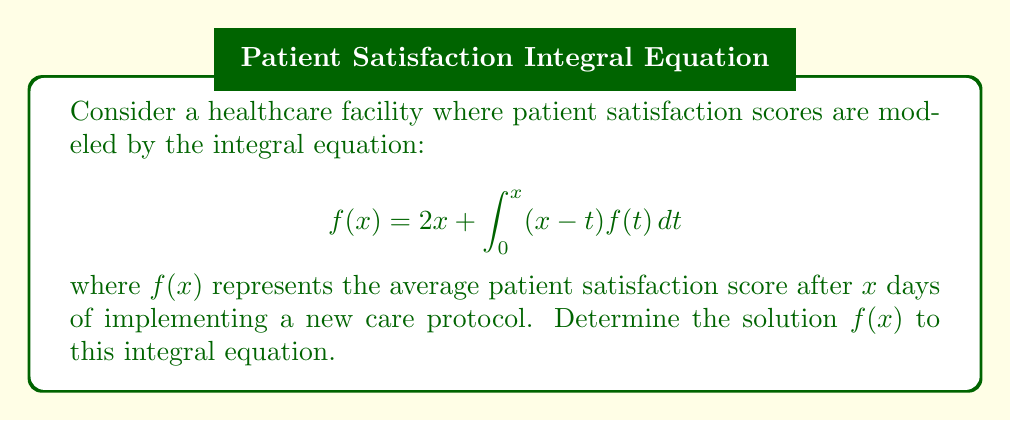Teach me how to tackle this problem. Let's solve this step-by-step:

1) First, we differentiate both sides of the equation with respect to $x$:

   $$f'(x) = 2 + \int_0^x f(t)dt + (x-x)f(x) = 2 + \int_0^x f(t)dt$$

2) Differentiating again:

   $$f''(x) = f(x)$$

3) This is a second-order differential equation. The general solution is:

   $$f(x) = A e^x + B e^{-x}$$

4) To find $A$ and $B$, we use the initial conditions. From the original equation:

   At $x = 0$: $f(0) = 2(0) + 0 = 0$
   
   So, $A + B = 0$ or $B = -A$

5) Substituting the general solution into the original equation:

   $$A e^x - A e^{-x} = 2x + \int_0^x (x-t)(A e^t - A e^{-t})dt$$

6) Evaluating the integral:

   $$A e^x - A e^{-x} = 2x + A(x e^x - e^x + 1) - A(x e^{-x} + e^{-x} - 1)$$

7) Simplifying:

   $$A e^x - A e^{-x} = 2x + Ax e^x - A e^x + A - Ax e^{-x} - A e^{-x} + A$$

8) Cancelling terms:

   $$2A = 2x$$

9) Therefore, $A = x$ and $B = -x$

Thus, the solution is:

$$f(x) = x(e^x - e^{-x})$$
Answer: $f(x) = x(e^x - e^{-x})$ 